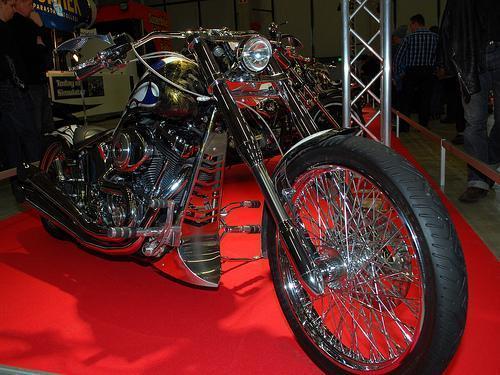How many motorcycles are photographed?
Give a very brief answer. 1. 